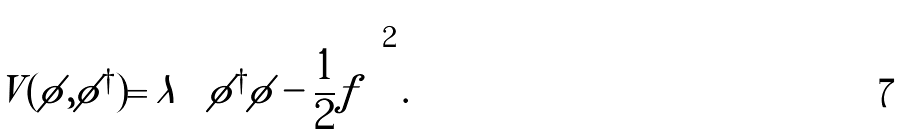Convert formula to latex. <formula><loc_0><loc_0><loc_500><loc_500>V ( \phi , \phi ^ { \dagger } ) = \lambda \left ( \phi ^ { \dagger } \phi - \frac { 1 } { 2 } f \right ) ^ { 2 } .</formula> 